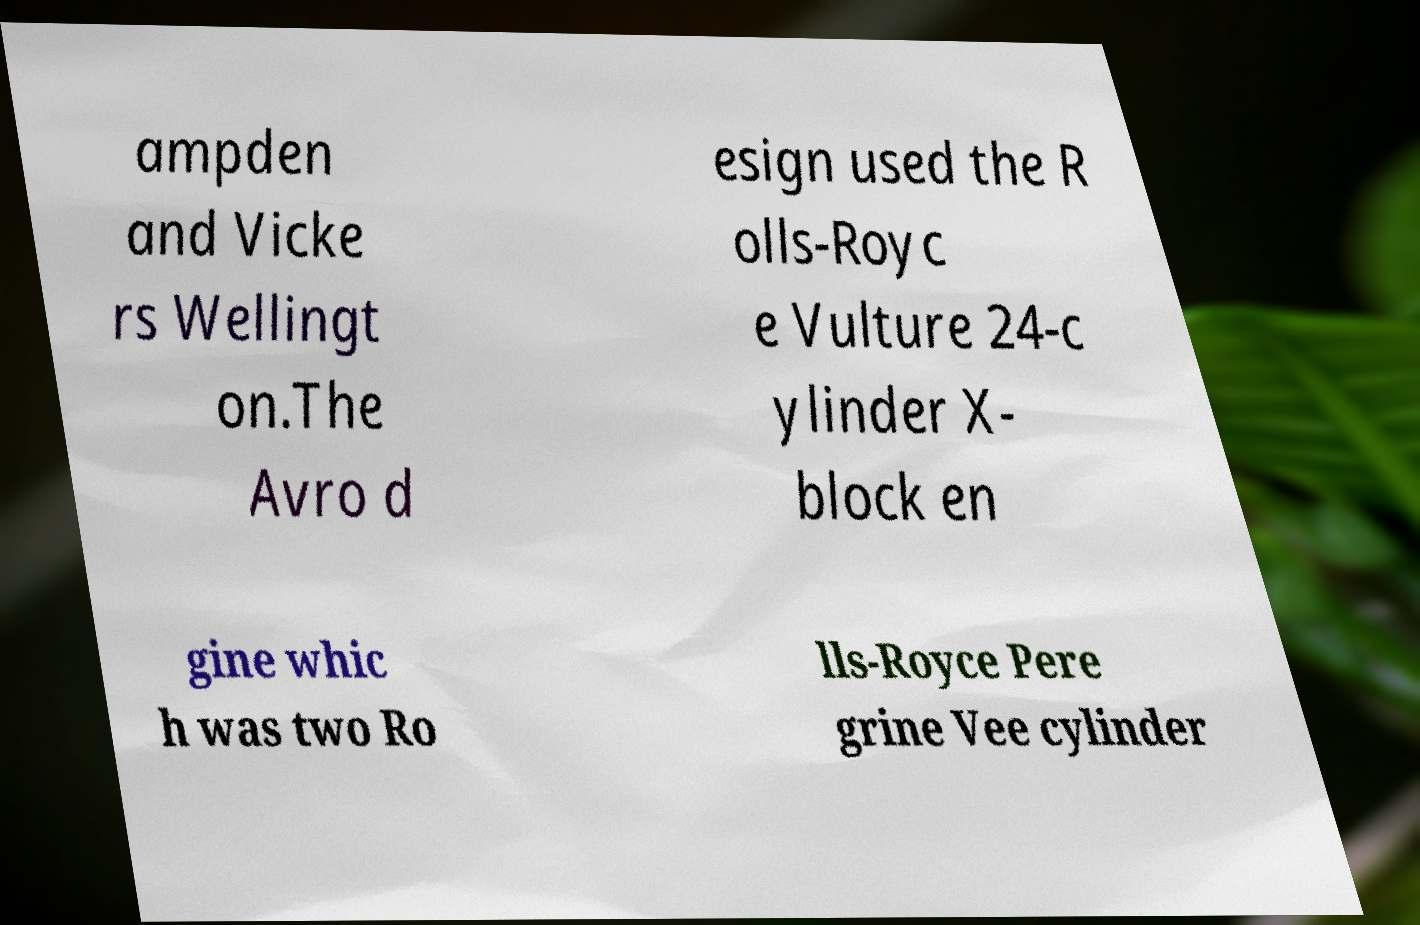I need the written content from this picture converted into text. Can you do that? ampden and Vicke rs Wellingt on.The Avro d esign used the R olls-Royc e Vulture 24-c ylinder X- block en gine whic h was two Ro lls-Royce Pere grine Vee cylinder 